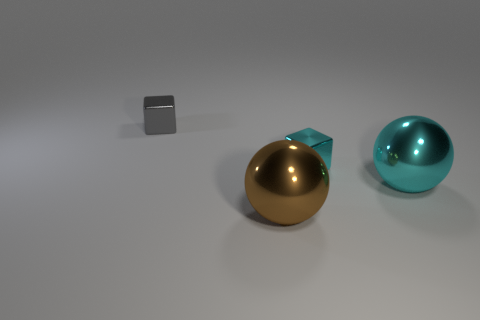There is a sphere to the left of the sphere that is behind the big shiny thing that is in front of the large cyan object; how big is it?
Provide a succinct answer. Large. What number of other big things are made of the same material as the big cyan object?
Your answer should be very brief. 1. How many other cyan balls are the same size as the cyan ball?
Keep it short and to the point. 0. There is a cyan thing behind the big metal object that is behind the big thing on the left side of the large cyan sphere; what is it made of?
Provide a succinct answer. Metal. How many things are either cyan cylinders or tiny cubes?
Provide a succinct answer. 2. Is there anything else that is made of the same material as the large brown sphere?
Make the answer very short. Yes. What is the shape of the small cyan metallic thing?
Provide a succinct answer. Cube. There is a large metallic thing that is to the right of the small block that is in front of the tiny gray object; what is its shape?
Your response must be concise. Sphere. Do the tiny cube in front of the tiny gray object and the large cyan sphere have the same material?
Your answer should be compact. Yes. What number of cyan objects are spheres or tiny shiny things?
Provide a short and direct response. 2. 